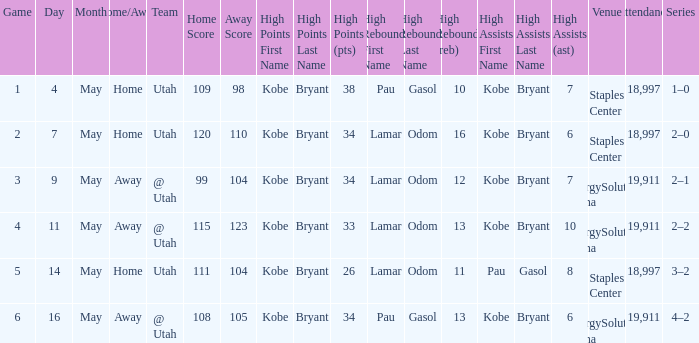What is the High rebounds with a Series with 4–2? Gasol (13). 